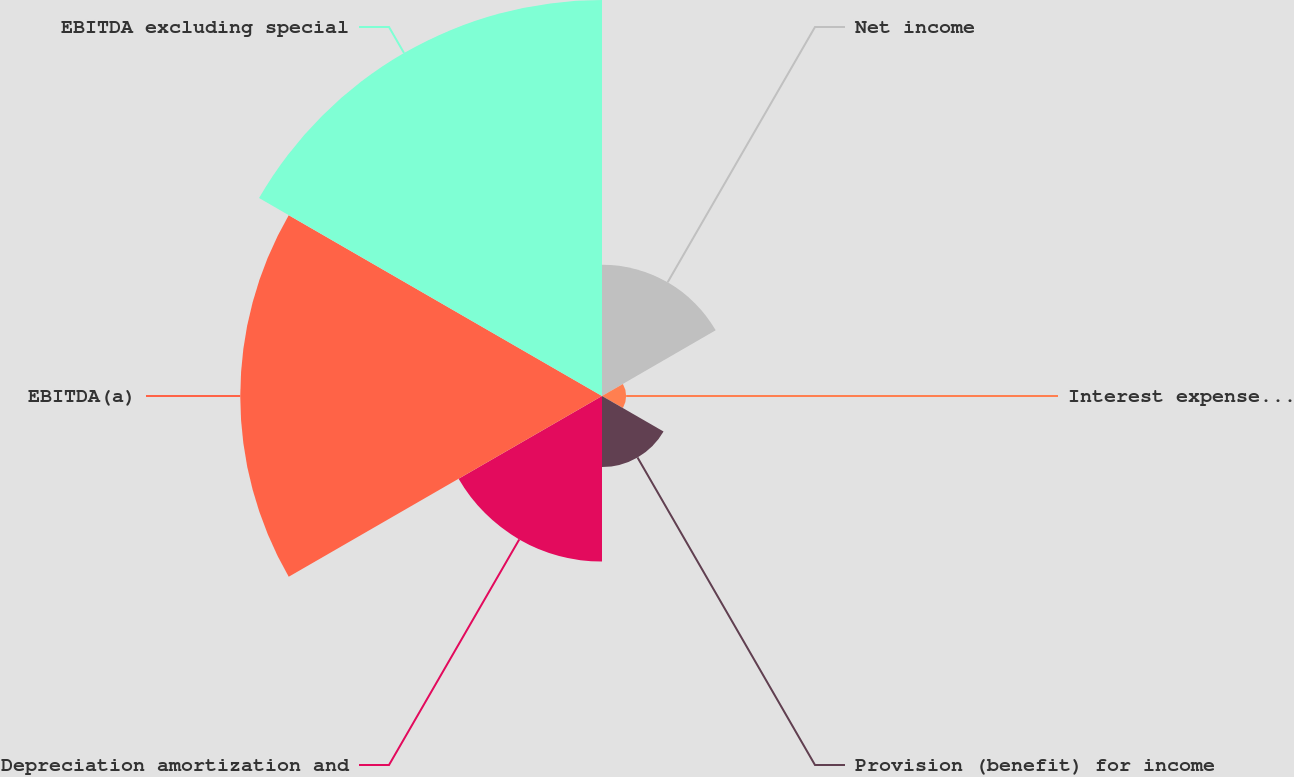<chart> <loc_0><loc_0><loc_500><loc_500><pie_chart><fcel>Net income<fcel>Interest expense net<fcel>Provision (benefit) for income<fcel>Depreciation amortization and<fcel>EBITDA(a)<fcel>EBITDA excluding special<nl><fcel>11.42%<fcel>2.1%<fcel>6.18%<fcel>14.4%<fcel>31.46%<fcel>34.44%<nl></chart> 